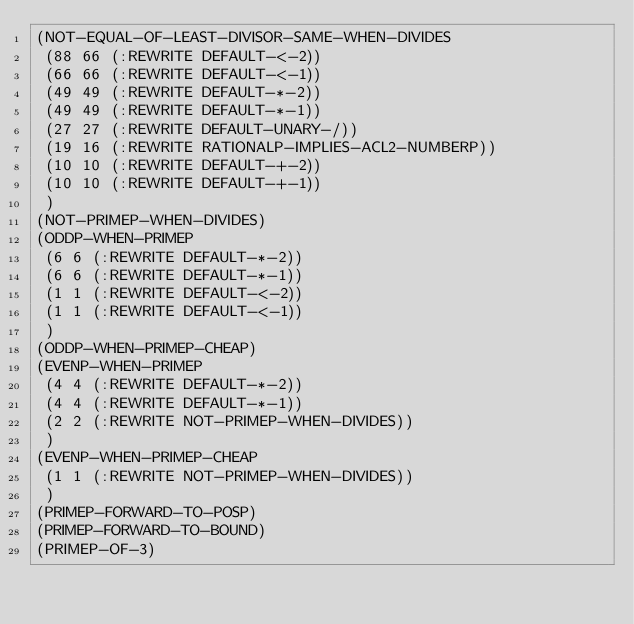Convert code to text. <code><loc_0><loc_0><loc_500><loc_500><_Lisp_>(NOT-EQUAL-OF-LEAST-DIVISOR-SAME-WHEN-DIVIDES
 (88 66 (:REWRITE DEFAULT-<-2))
 (66 66 (:REWRITE DEFAULT-<-1))
 (49 49 (:REWRITE DEFAULT-*-2))
 (49 49 (:REWRITE DEFAULT-*-1))
 (27 27 (:REWRITE DEFAULT-UNARY-/))
 (19 16 (:REWRITE RATIONALP-IMPLIES-ACL2-NUMBERP))
 (10 10 (:REWRITE DEFAULT-+-2))
 (10 10 (:REWRITE DEFAULT-+-1))
 )
(NOT-PRIMEP-WHEN-DIVIDES)
(ODDP-WHEN-PRIMEP
 (6 6 (:REWRITE DEFAULT-*-2))
 (6 6 (:REWRITE DEFAULT-*-1))
 (1 1 (:REWRITE DEFAULT-<-2))
 (1 1 (:REWRITE DEFAULT-<-1))
 )
(ODDP-WHEN-PRIMEP-CHEAP)
(EVENP-WHEN-PRIMEP
 (4 4 (:REWRITE DEFAULT-*-2))
 (4 4 (:REWRITE DEFAULT-*-1))
 (2 2 (:REWRITE NOT-PRIMEP-WHEN-DIVIDES))
 )
(EVENP-WHEN-PRIMEP-CHEAP
 (1 1 (:REWRITE NOT-PRIMEP-WHEN-DIVIDES))
 )
(PRIMEP-FORWARD-TO-POSP)
(PRIMEP-FORWARD-TO-BOUND)
(PRIMEP-OF-3)
</code> 